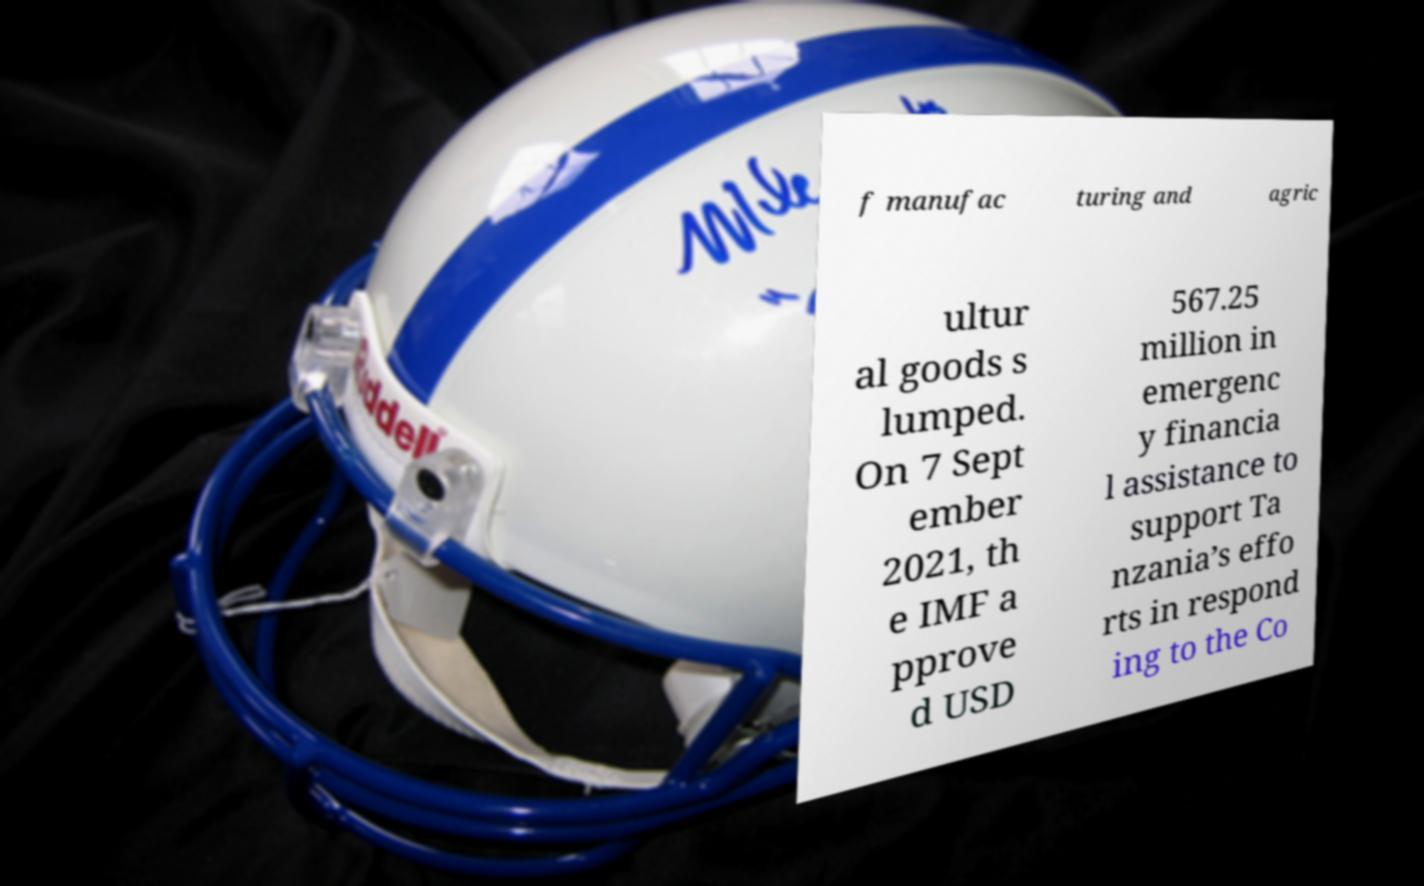I need the written content from this picture converted into text. Can you do that? f manufac turing and agric ultur al goods s lumped. On 7 Sept ember 2021, th e IMF a pprove d USD 567.25 million in emergenc y financia l assistance to support Ta nzania’s effo rts in respond ing to the Co 